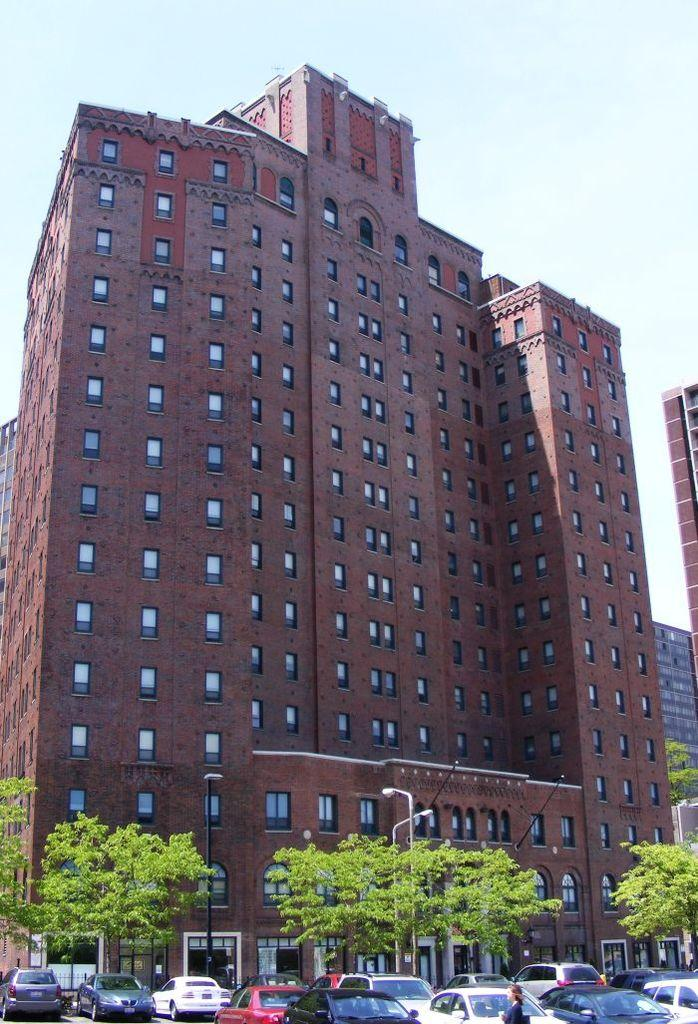What type of structures can be seen in the image? There are buildings in the image. What other natural elements are present in the image? There are trees in the image. What type of vehicles can be seen at the bottom of the image? Cars are visible at the bottom of the image. What is visible in the background of the image? The sky is visible in the background of the image. What is the name of the ship in the image? There is no ship present in the image. Can you tell me the name of the person who owns the card in the image? There is no card or person's name mentioned in the image. 